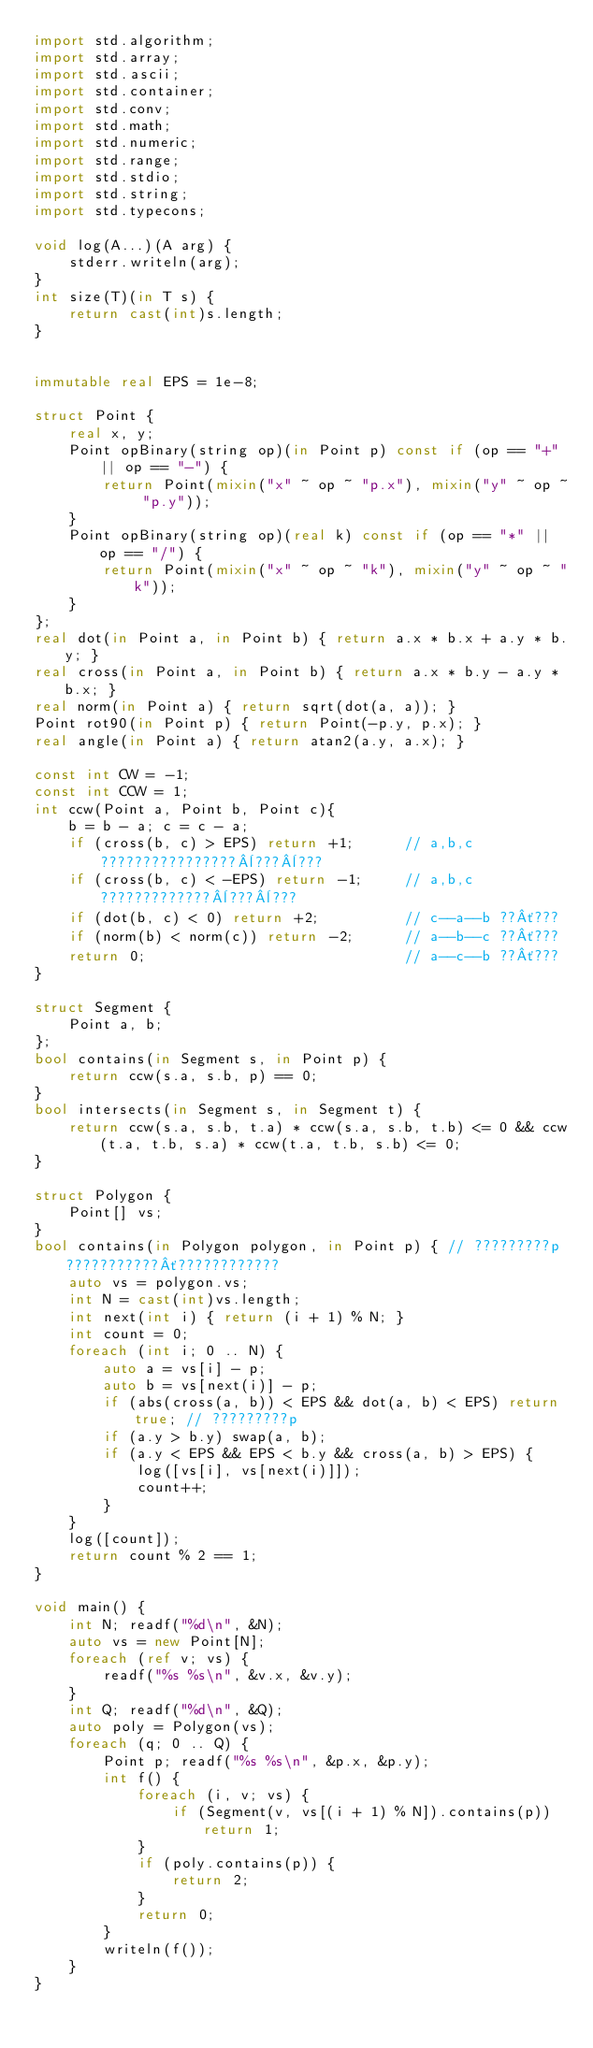<code> <loc_0><loc_0><loc_500><loc_500><_D_>import std.algorithm;
import std.array;
import std.ascii;
import std.container;
import std.conv;
import std.math;
import std.numeric;
import std.range;
import std.stdio;
import std.string;
import std.typecons;

void log(A...)(A arg) {
    stderr.writeln(arg);
}
int size(T)(in T s) {
    return cast(int)s.length;
}


immutable real EPS = 1e-8;

struct Point {
    real x, y;
    Point opBinary(string op)(in Point p) const if (op == "+" || op == "-") {
        return Point(mixin("x" ~ op ~ "p.x"), mixin("y" ~ op ~ "p.y"));
    }
    Point opBinary(string op)(real k) const if (op == "*" || op == "/") {
        return Point(mixin("x" ~ op ~ "k"), mixin("y" ~ op ~ "k"));
    }
};
real dot(in Point a, in Point b) { return a.x * b.x + a.y * b.y; }
real cross(in Point a, in Point b) { return a.x * b.y - a.y * b.x; }
real norm(in Point a) { return sqrt(dot(a, a)); }
Point rot90(in Point p) { return Point(-p.y, p.x); }
real angle(in Point a) { return atan2(a.y, a.x); }

const int CW = -1;
const int CCW = 1;
int ccw(Point a, Point b, Point c){
    b = b - a; c = c - a;                                          
    if (cross(b, c) > EPS) return +1;      // a,b,c????????????????¨???¨???
    if (cross(b, c) < -EPS) return -1;     // a,b,c?????????????¨???¨???                       
    if (dot(b, c) < 0) return +2;          // c--a--b ??´???                       
    if (norm(b) < norm(c)) return -2;      // a--b--c ??´???                       
    return 0;                              // a--c--b ??´???
}

struct Segment {
    Point a, b;
};
bool contains(in Segment s, in Point p) {
    return ccw(s.a, s.b, p) == 0;
}
bool intersects(in Segment s, in Segment t) {
    return ccw(s.a, s.b, t.a) * ccw(s.a, s.b, t.b) <= 0 && ccw(t.a, t.b, s.a) * ccw(t.a, t.b, s.b) <= 0;
}

struct Polygon {
    Point[] vs;
}
bool contains(in Polygon polygon, in Point p) { // ?????????p???????????´????????????
    auto vs = polygon.vs;
    int N = cast(int)vs.length;
    int next(int i) { return (i + 1) % N; }
    int count = 0;
    foreach (int i; 0 .. N) {
        auto a = vs[i] - p;
        auto b = vs[next(i)] - p;
        if (abs(cross(a, b)) < EPS && dot(a, b) < EPS) return true; // ?????????p
        if (a.y > b.y) swap(a, b);
        if (a.y < EPS && EPS < b.y && cross(a, b) > EPS) {
            log([vs[i], vs[next(i)]]);
            count++;
        }
    }
    log([count]);
    return count % 2 == 1;
}

void main() {
    int N; readf("%d\n", &N);
    auto vs = new Point[N];
    foreach (ref v; vs) {
        readf("%s %s\n", &v.x, &v.y);
    }
    int Q; readf("%d\n", &Q);
    auto poly = Polygon(vs);
    foreach (q; 0 .. Q) {
        Point p; readf("%s %s\n", &p.x, &p.y);
        int f() {
            foreach (i, v; vs) {
                if (Segment(v, vs[(i + 1) % N]).contains(p)) return 1;
            }
            if (poly.contains(p)) {
                return 2;
            }
            return 0;
        }
        writeln(f());
    }
}</code> 